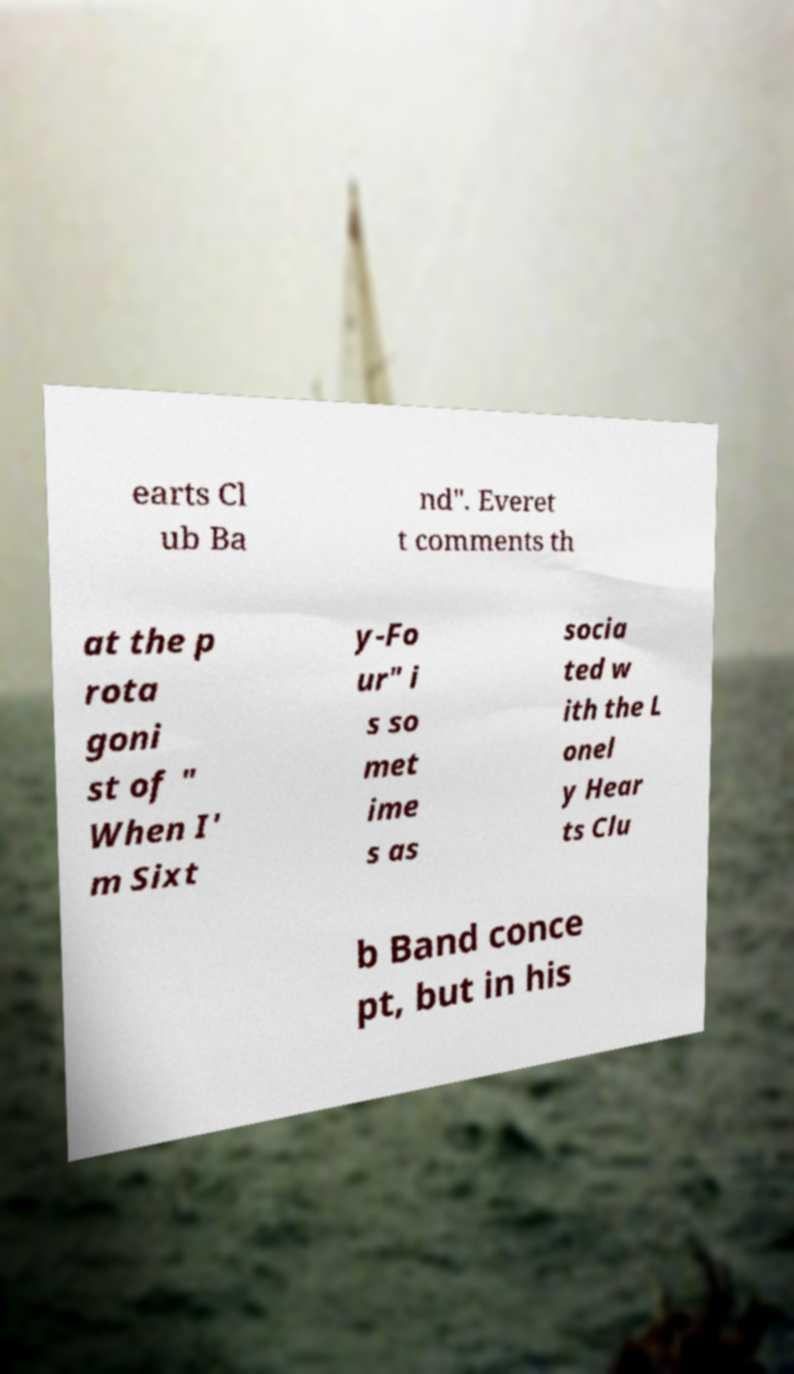Can you accurately transcribe the text from the provided image for me? earts Cl ub Ba nd". Everet t comments th at the p rota goni st of " When I' m Sixt y-Fo ur" i s so met ime s as socia ted w ith the L onel y Hear ts Clu b Band conce pt, but in his 